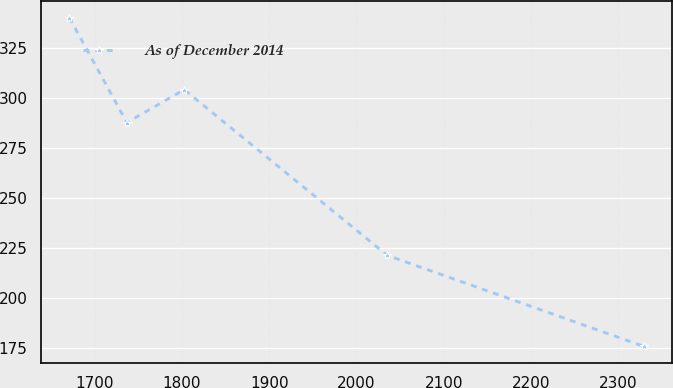<chart> <loc_0><loc_0><loc_500><loc_500><line_chart><ecel><fcel>As of December 2014<nl><fcel>1671.21<fcel>340.25<nl><fcel>1736.99<fcel>287.74<nl><fcel>1802.77<fcel>304.2<nl><fcel>2035.31<fcel>221.22<nl><fcel>2328.99<fcel>175.69<nl></chart> 